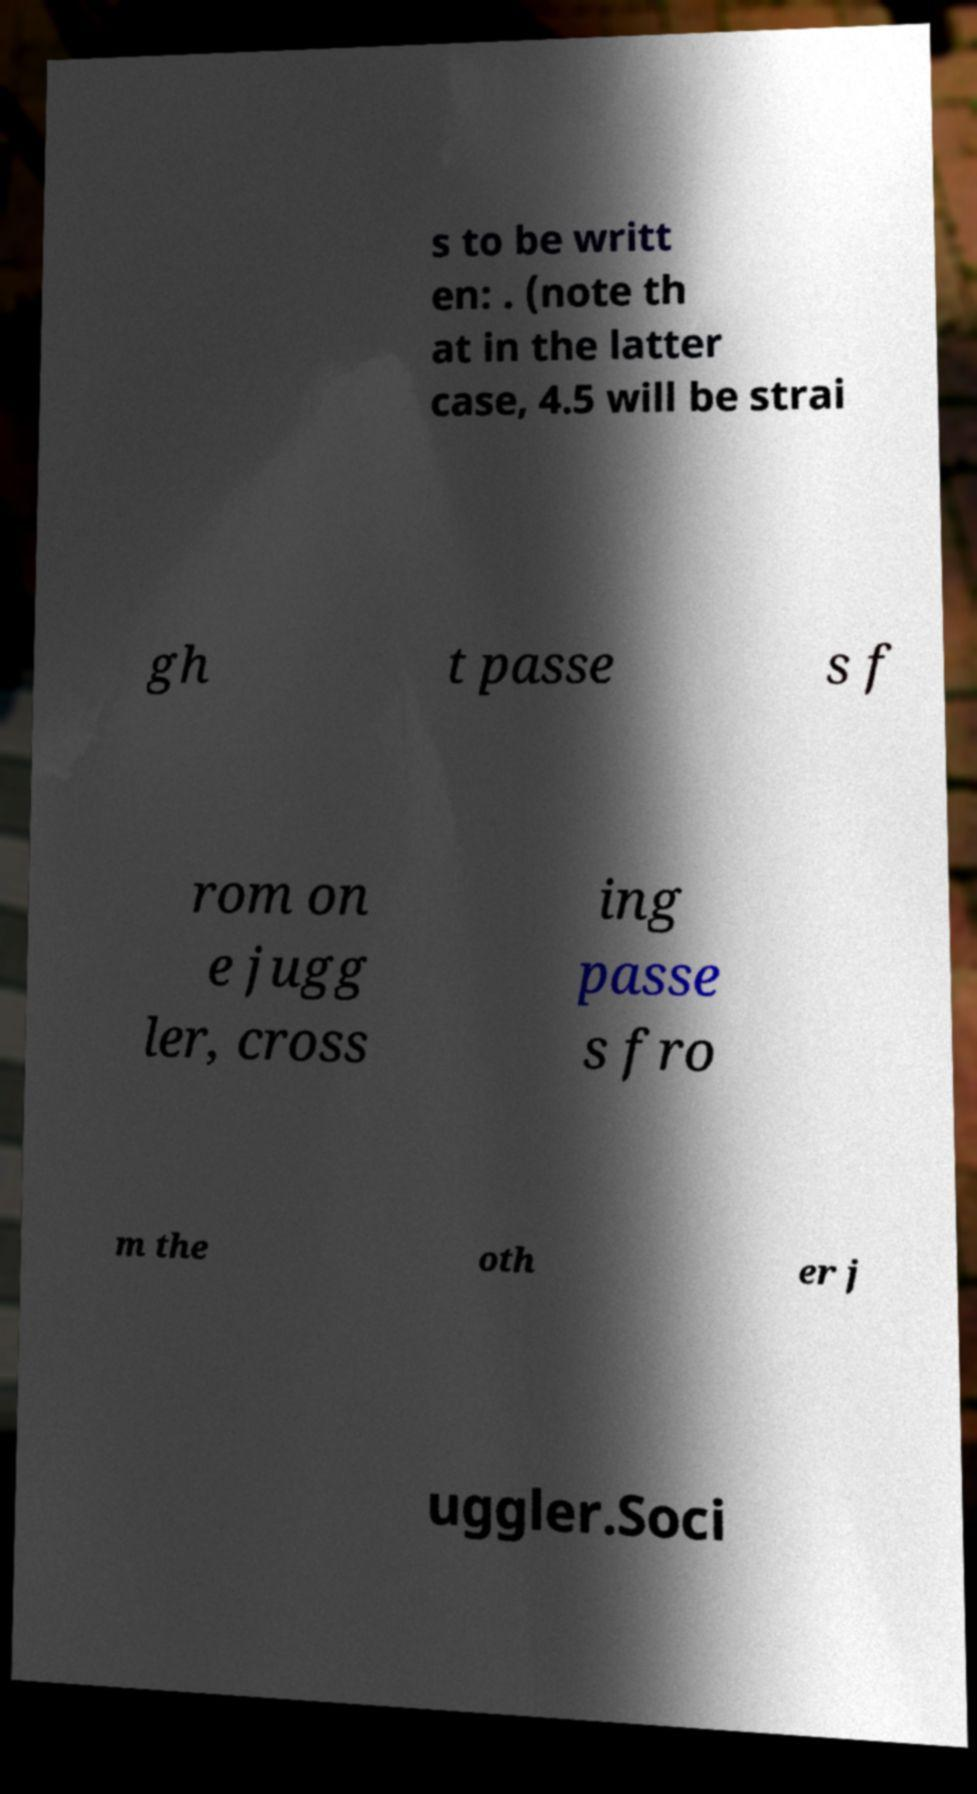There's text embedded in this image that I need extracted. Can you transcribe it verbatim? s to be writt en: . (note th at in the latter case, 4.5 will be strai gh t passe s f rom on e jugg ler, cross ing passe s fro m the oth er j uggler.Soci 